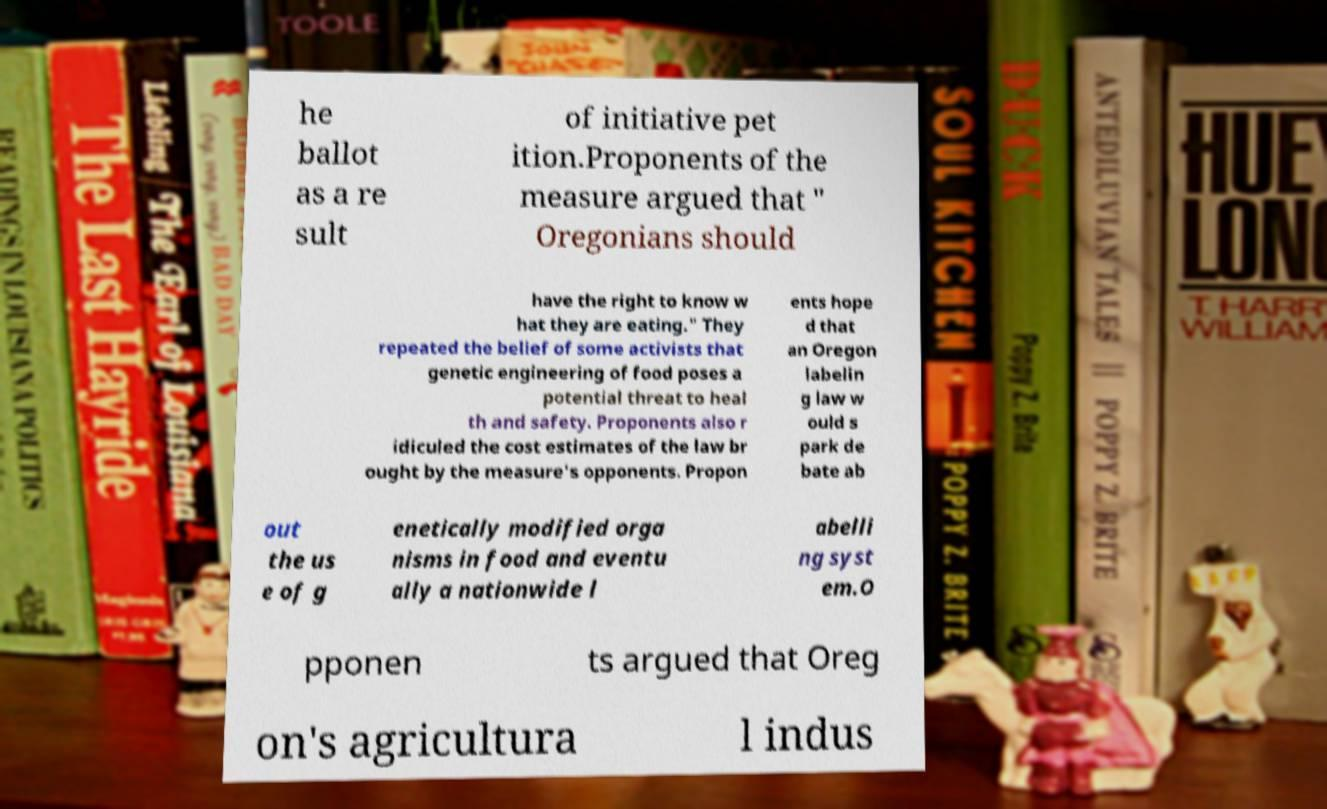For documentation purposes, I need the text within this image transcribed. Could you provide that? he ballot as a re sult of initiative pet ition.Proponents of the measure argued that " Oregonians should have the right to know w hat they are eating." They repeated the belief of some activists that genetic engineering of food poses a potential threat to heal th and safety. Proponents also r idiculed the cost estimates of the law br ought by the measure's opponents. Propon ents hope d that an Oregon labelin g law w ould s park de bate ab out the us e of g enetically modified orga nisms in food and eventu ally a nationwide l abelli ng syst em.O pponen ts argued that Oreg on's agricultura l indus 